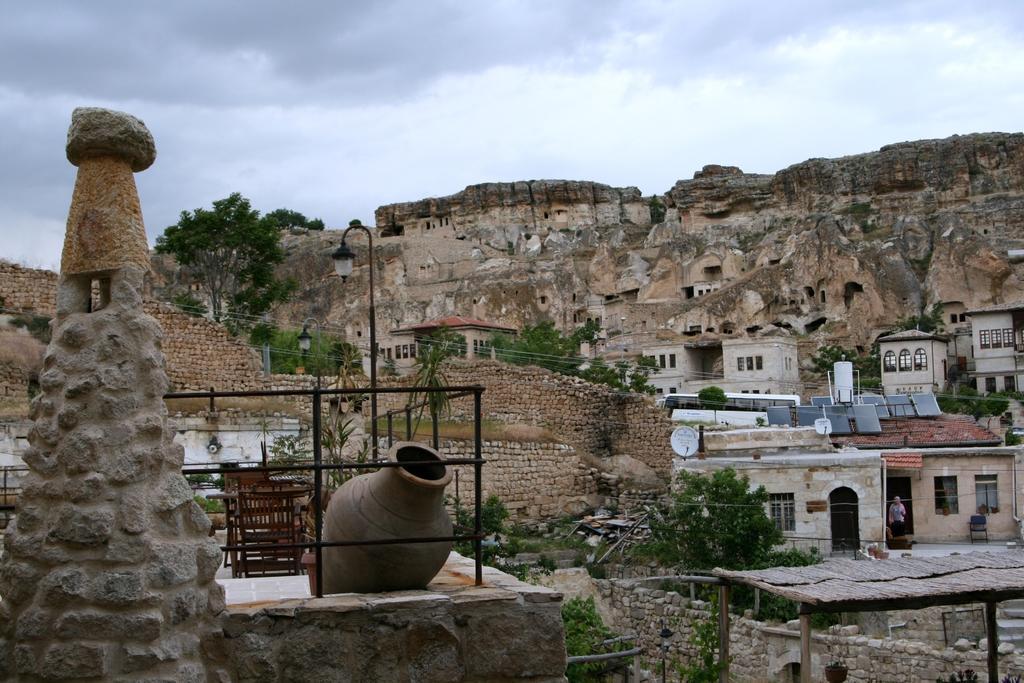Could you give a brief overview of what you see in this image? This image is taken outdoors. At the top of the image there is the sky with clouds. In the middle of the image there are a few hills. There is a fort. There are a few houses with walls, windows, doors and roofs. There are a few trees and there are a few brick walls. On the left side of the image there is an architecture and there is a railing and there is a pot on the floor. There are a few poles with street lights and a few wires. 